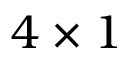Convert formula to latex. <formula><loc_0><loc_0><loc_500><loc_500>4 \times 1</formula> 